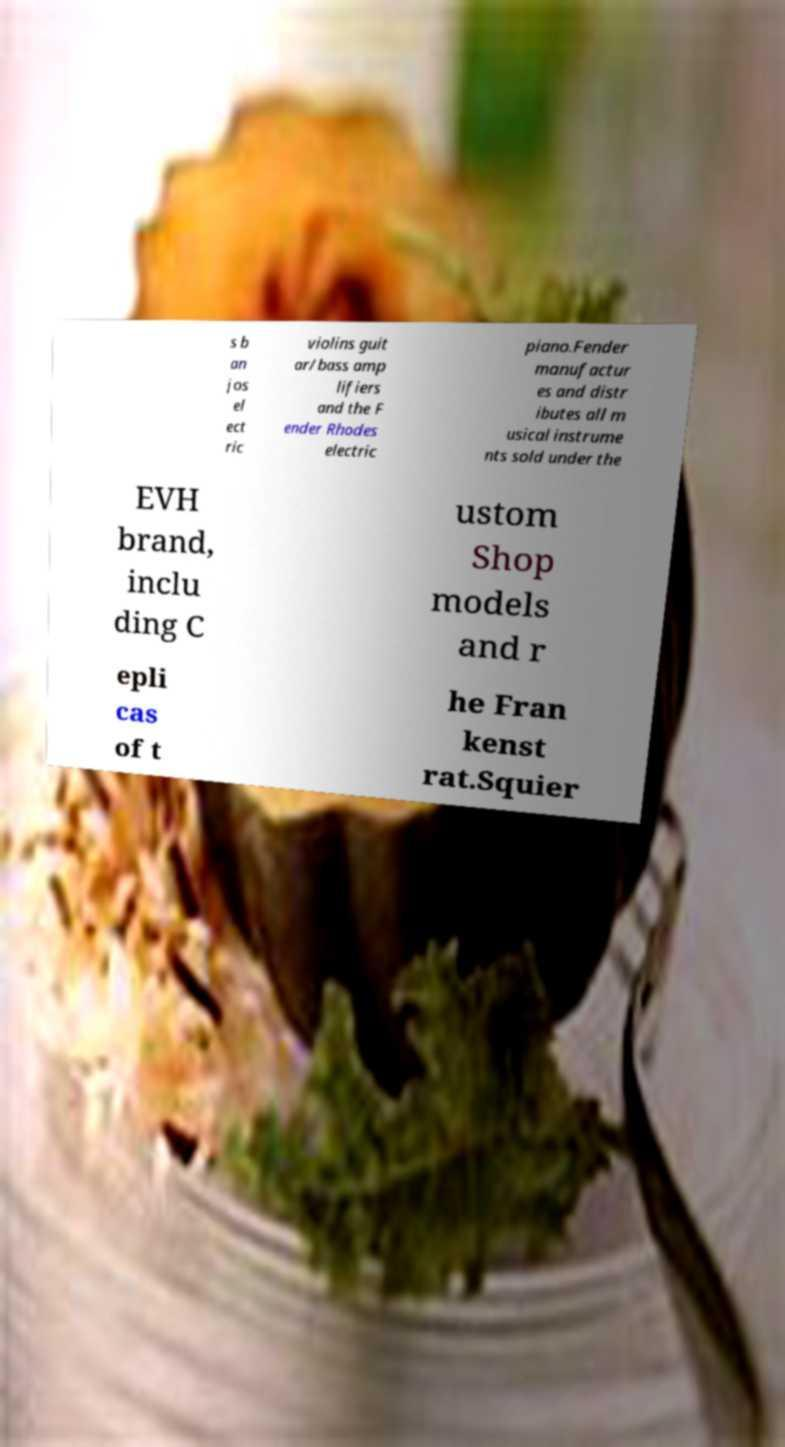I need the written content from this picture converted into text. Can you do that? s b an jos el ect ric violins guit ar/bass amp lifiers and the F ender Rhodes electric piano.Fender manufactur es and distr ibutes all m usical instrume nts sold under the EVH brand, inclu ding C ustom Shop models and r epli cas of t he Fran kenst rat.Squier 